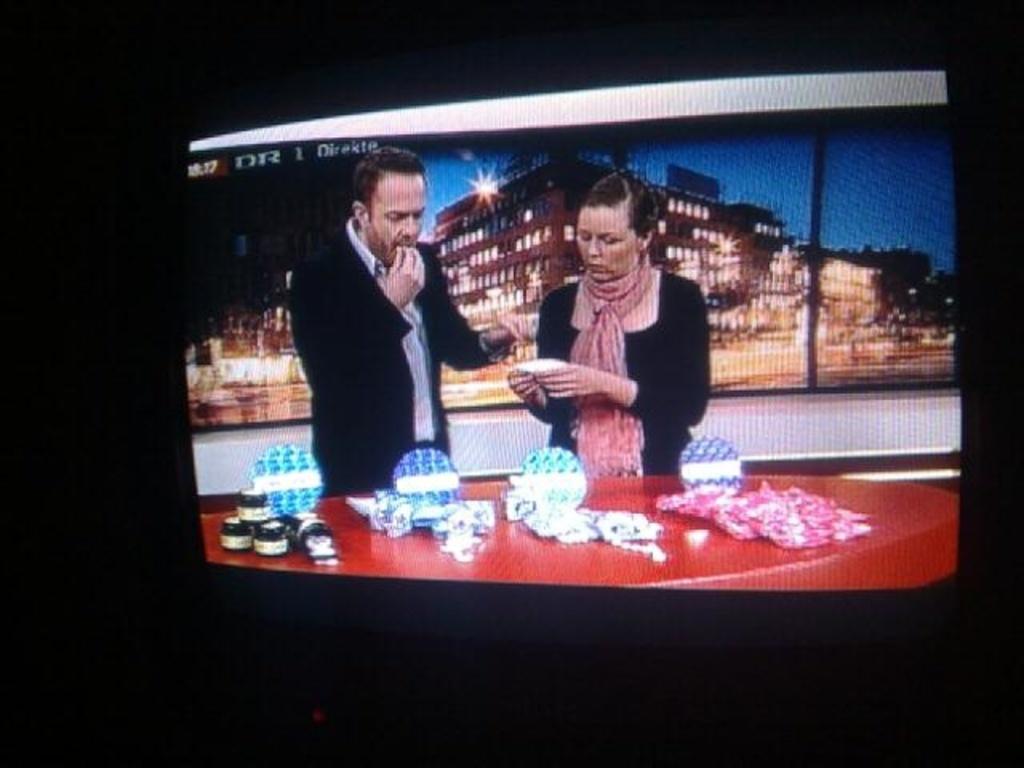What initials are written in capitals on the top left corner?
Your answer should be very brief. Dr. 